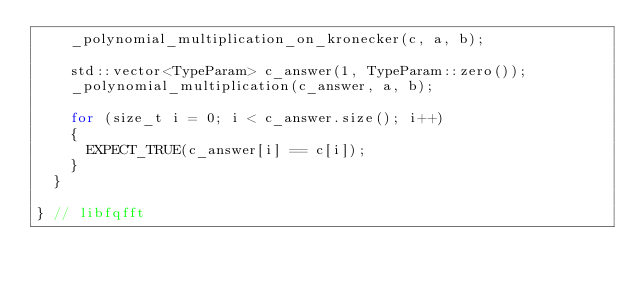Convert code to text. <code><loc_0><loc_0><loc_500><loc_500><_C++_>    _polynomial_multiplication_on_kronecker(c, a, b);
    
    std::vector<TypeParam> c_answer(1, TypeParam::zero());
    _polynomial_multiplication(c_answer, a, b);

    for (size_t i = 0; i < c_answer.size(); i++)
    {
      EXPECT_TRUE(c_answer[i] == c[i]);
    }
  }

} // libfqfft
</code> 